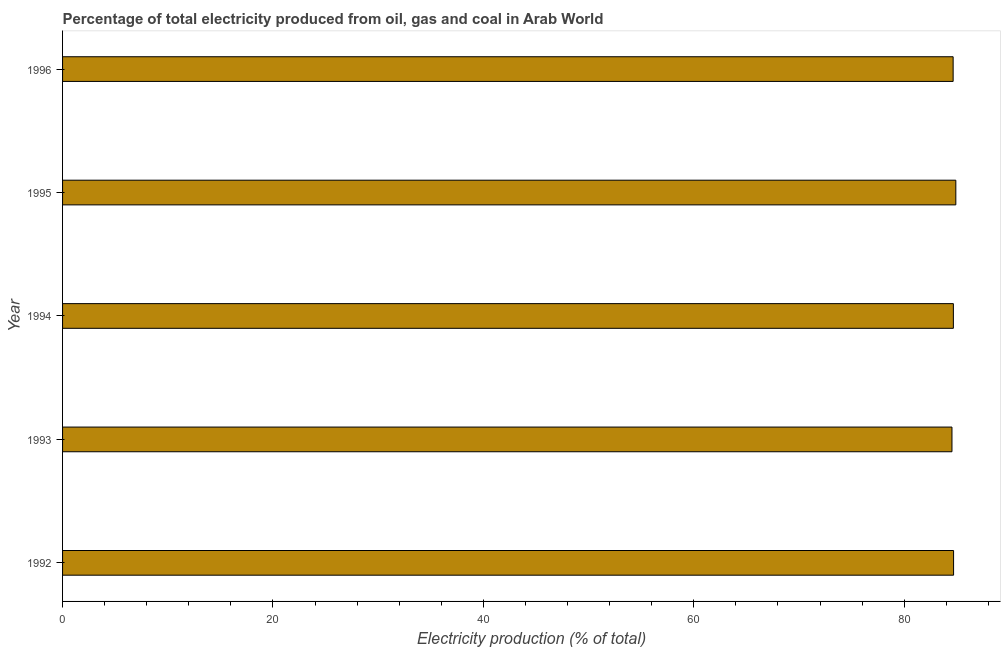What is the title of the graph?
Keep it short and to the point. Percentage of total electricity produced from oil, gas and coal in Arab World. What is the label or title of the X-axis?
Your answer should be compact. Electricity production (% of total). What is the electricity production in 1994?
Provide a short and direct response. 84.67. Across all years, what is the maximum electricity production?
Provide a short and direct response. 84.91. Across all years, what is the minimum electricity production?
Offer a terse response. 84.54. In which year was the electricity production maximum?
Make the answer very short. 1995. What is the sum of the electricity production?
Your response must be concise. 423.47. What is the difference between the electricity production in 1993 and 1995?
Offer a very short reply. -0.37. What is the average electricity production per year?
Keep it short and to the point. 84.69. What is the median electricity production?
Provide a short and direct response. 84.67. Is the difference between the electricity production in 1992 and 1996 greater than the difference between any two years?
Offer a terse response. No. What is the difference between the highest and the second highest electricity production?
Provide a short and direct response. 0.21. What is the difference between the highest and the lowest electricity production?
Ensure brevity in your answer.  0.37. Are all the bars in the graph horizontal?
Your answer should be compact. Yes. How many years are there in the graph?
Make the answer very short. 5. What is the difference between two consecutive major ticks on the X-axis?
Give a very brief answer. 20. What is the Electricity production (% of total) in 1992?
Make the answer very short. 84.69. What is the Electricity production (% of total) of 1993?
Provide a succinct answer. 84.54. What is the Electricity production (% of total) of 1994?
Your answer should be compact. 84.67. What is the Electricity production (% of total) in 1995?
Give a very brief answer. 84.91. What is the Electricity production (% of total) in 1996?
Your response must be concise. 84.65. What is the difference between the Electricity production (% of total) in 1992 and 1993?
Provide a succinct answer. 0.15. What is the difference between the Electricity production (% of total) in 1992 and 1994?
Give a very brief answer. 0.02. What is the difference between the Electricity production (% of total) in 1992 and 1995?
Your answer should be compact. -0.21. What is the difference between the Electricity production (% of total) in 1992 and 1996?
Your answer should be compact. 0.04. What is the difference between the Electricity production (% of total) in 1993 and 1994?
Make the answer very short. -0.13. What is the difference between the Electricity production (% of total) in 1993 and 1995?
Your answer should be compact. -0.37. What is the difference between the Electricity production (% of total) in 1993 and 1996?
Keep it short and to the point. -0.11. What is the difference between the Electricity production (% of total) in 1994 and 1995?
Keep it short and to the point. -0.23. What is the difference between the Electricity production (% of total) in 1994 and 1996?
Ensure brevity in your answer.  0.02. What is the difference between the Electricity production (% of total) in 1995 and 1996?
Ensure brevity in your answer.  0.26. What is the ratio of the Electricity production (% of total) in 1992 to that in 1993?
Your answer should be compact. 1. What is the ratio of the Electricity production (% of total) in 1992 to that in 1994?
Ensure brevity in your answer.  1. What is the ratio of the Electricity production (% of total) in 1992 to that in 1995?
Offer a very short reply. 1. What is the ratio of the Electricity production (% of total) in 1992 to that in 1996?
Offer a very short reply. 1. What is the ratio of the Electricity production (% of total) in 1993 to that in 1994?
Provide a succinct answer. 1. 